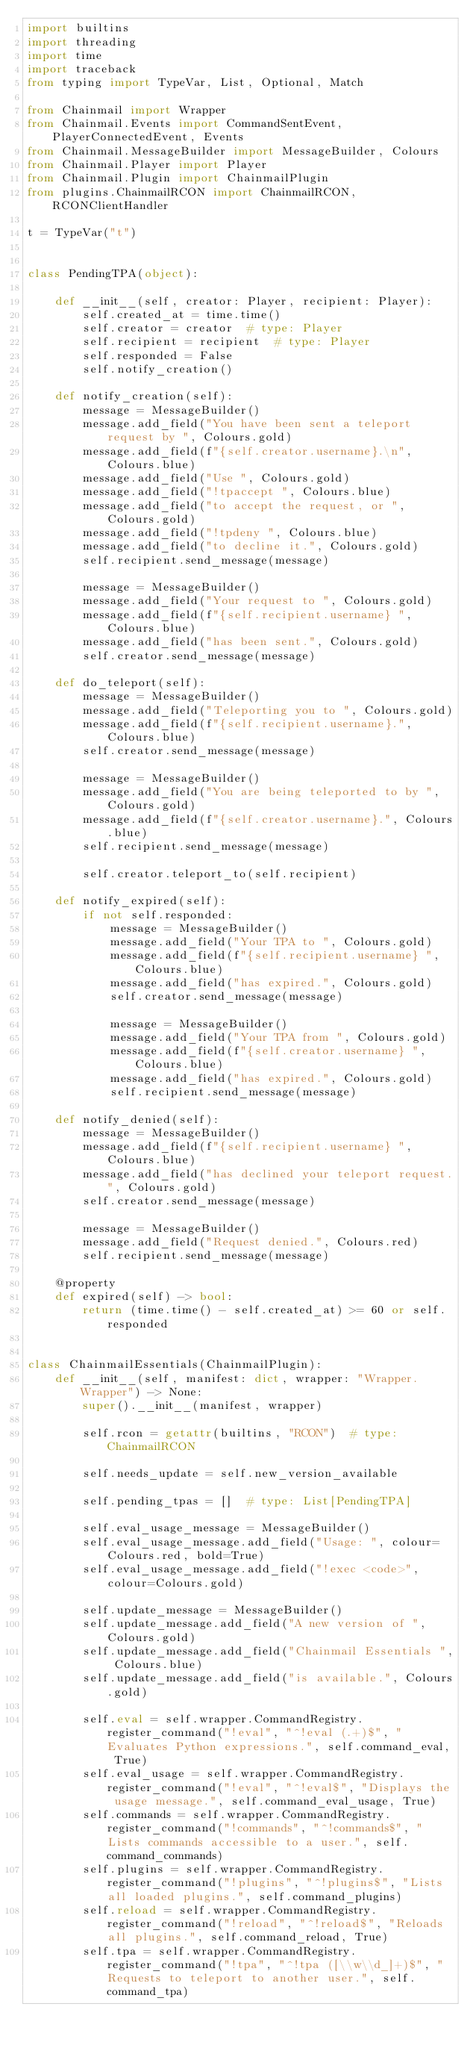<code> <loc_0><loc_0><loc_500><loc_500><_Python_>import builtins
import threading
import time
import traceback
from typing import TypeVar, List, Optional, Match

from Chainmail import Wrapper
from Chainmail.Events import CommandSentEvent, PlayerConnectedEvent, Events
from Chainmail.MessageBuilder import MessageBuilder, Colours
from Chainmail.Player import Player
from Chainmail.Plugin import ChainmailPlugin
from plugins.ChainmailRCON import ChainmailRCON, RCONClientHandler

t = TypeVar("t")


class PendingTPA(object):

    def __init__(self, creator: Player, recipient: Player):
        self.created_at = time.time()
        self.creator = creator  # type: Player
        self.recipient = recipient  # type: Player
        self.responded = False
        self.notify_creation()

    def notify_creation(self):
        message = MessageBuilder()
        message.add_field("You have been sent a teleport request by ", Colours.gold)
        message.add_field(f"{self.creator.username}.\n", Colours.blue)
        message.add_field("Use ", Colours.gold)
        message.add_field("!tpaccept ", Colours.blue)
        message.add_field("to accept the request, or ", Colours.gold)
        message.add_field("!tpdeny ", Colours.blue)
        message.add_field("to decline it.", Colours.gold)
        self.recipient.send_message(message)

        message = MessageBuilder()
        message.add_field("Your request to ", Colours.gold)
        message.add_field(f"{self.recipient.username} ", Colours.blue)
        message.add_field("has been sent.", Colours.gold)
        self.creator.send_message(message)

    def do_teleport(self):
        message = MessageBuilder()
        message.add_field("Teleporting you to ", Colours.gold)
        message.add_field(f"{self.recipient.username}.", Colours.blue)
        self.creator.send_message(message)

        message = MessageBuilder()
        message.add_field("You are being teleported to by ", Colours.gold)
        message.add_field(f"{self.creator.username}.", Colours.blue)
        self.recipient.send_message(message)

        self.creator.teleport_to(self.recipient)

    def notify_expired(self):
        if not self.responded:
            message = MessageBuilder()
            message.add_field("Your TPA to ", Colours.gold)
            message.add_field(f"{self.recipient.username} ", Colours.blue)
            message.add_field("has expired.", Colours.gold)
            self.creator.send_message(message)

            message = MessageBuilder()
            message.add_field("Your TPA from ", Colours.gold)
            message.add_field(f"{self.creator.username} ", Colours.blue)
            message.add_field("has expired.", Colours.gold)
            self.recipient.send_message(message)

    def notify_denied(self):
        message = MessageBuilder()
        message.add_field(f"{self.recipient.username} ", Colours.blue)
        message.add_field("has declined your teleport request.", Colours.gold)
        self.creator.send_message(message)

        message = MessageBuilder()
        message.add_field("Request denied.", Colours.red)
        self.recipient.send_message(message)

    @property
    def expired(self) -> bool:
        return (time.time() - self.created_at) >= 60 or self.responded


class ChainmailEssentials(ChainmailPlugin):
    def __init__(self, manifest: dict, wrapper: "Wrapper.Wrapper") -> None:
        super().__init__(manifest, wrapper)

        self.rcon = getattr(builtins, "RCON")  # type: ChainmailRCON

        self.needs_update = self.new_version_available

        self.pending_tpas = []  # type: List[PendingTPA]

        self.eval_usage_message = MessageBuilder()
        self.eval_usage_message.add_field("Usage: ", colour=Colours.red, bold=True)
        self.eval_usage_message.add_field("!exec <code>", colour=Colours.gold)

        self.update_message = MessageBuilder()
        self.update_message.add_field("A new version of ", Colours.gold)
        self.update_message.add_field("Chainmail Essentials ", Colours.blue)
        self.update_message.add_field("is available.", Colours.gold)

        self.eval = self.wrapper.CommandRegistry.register_command("!eval", "^!eval (.+)$", "Evaluates Python expressions.", self.command_eval, True)
        self.eval_usage = self.wrapper.CommandRegistry.register_command("!eval", "^!eval$", "Displays the usage message.", self.command_eval_usage, True)
        self.commands = self.wrapper.CommandRegistry.register_command("!commands", "^!commands$", "Lists commands accessible to a user.", self.command_commands)
        self.plugins = self.wrapper.CommandRegistry.register_command("!plugins", "^!plugins$", "Lists all loaded plugins.", self.command_plugins)
        self.reload = self.wrapper.CommandRegistry.register_command("!reload", "^!reload$", "Reloads all plugins.", self.command_reload, True)
        self.tpa = self.wrapper.CommandRegistry.register_command("!tpa", "^!tpa ([\\w\\d_]+)$", "Requests to teleport to another user.", self.command_tpa)</code> 